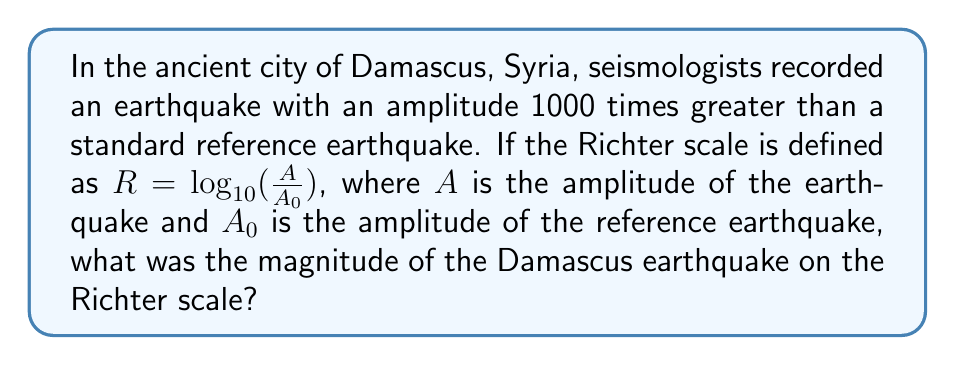What is the answer to this math problem? Let's approach this step-by-step:

1) We are given that the amplitude of the Damascus earthquake is 1000 times greater than the reference earthquake. This means:

   $\frac{A}{A_0} = 1000$

2) The Richter scale formula is:

   $R = \log_{10}(\frac{A}{A_0})$

3) We can substitute our known value into this formula:

   $R = \log_{10}(1000)$

4) Now, we need to calculate the logarithm. Remember, $1000 = 10^3$, so:

   $R = \log_{10}(10^3) = 3$

5) Therefore, the magnitude of the Damascus earthquake on the Richter scale is 3.
Answer: 3 